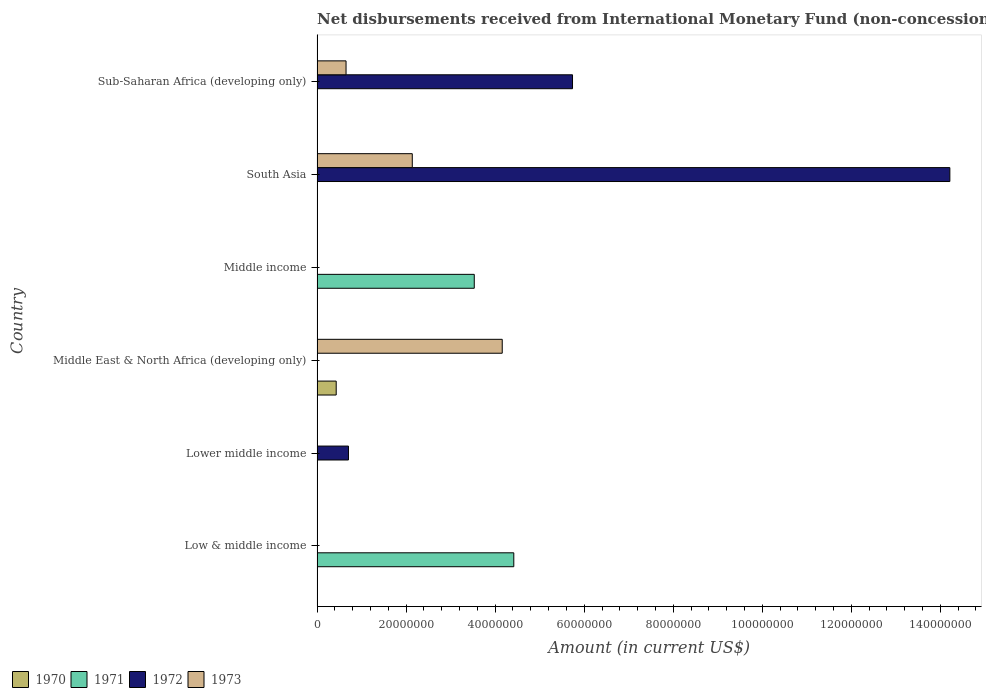Are the number of bars on each tick of the Y-axis equal?
Provide a short and direct response. No. What is the label of the 2nd group of bars from the top?
Your answer should be very brief. South Asia. What is the amount of disbursements received from International Monetary Fund in 1971 in Lower middle income?
Give a very brief answer. 0. Across all countries, what is the maximum amount of disbursements received from International Monetary Fund in 1972?
Your answer should be compact. 1.42e+08. Across all countries, what is the minimum amount of disbursements received from International Monetary Fund in 1973?
Offer a very short reply. 0. In which country was the amount of disbursements received from International Monetary Fund in 1970 maximum?
Your response must be concise. Middle East & North Africa (developing only). What is the total amount of disbursements received from International Monetary Fund in 1971 in the graph?
Ensure brevity in your answer.  7.95e+07. What is the difference between the amount of disbursements received from International Monetary Fund in 1971 in Low & middle income and that in Middle income?
Ensure brevity in your answer.  8.88e+06. What is the difference between the amount of disbursements received from International Monetary Fund in 1970 in South Asia and the amount of disbursements received from International Monetary Fund in 1972 in Sub-Saharan Africa (developing only)?
Offer a very short reply. -5.74e+07. What is the average amount of disbursements received from International Monetary Fund in 1973 per country?
Give a very brief answer. 1.16e+07. What is the difference between the amount of disbursements received from International Monetary Fund in 1973 and amount of disbursements received from International Monetary Fund in 1970 in Middle East & North Africa (developing only)?
Your answer should be compact. 3.73e+07. In how many countries, is the amount of disbursements received from International Monetary Fund in 1972 greater than 24000000 US$?
Keep it short and to the point. 2. Is the amount of disbursements received from International Monetary Fund in 1971 in Low & middle income less than that in Middle income?
Give a very brief answer. No. What is the difference between the highest and the second highest amount of disbursements received from International Monetary Fund in 1972?
Keep it short and to the point. 8.48e+07. What is the difference between the highest and the lowest amount of disbursements received from International Monetary Fund in 1973?
Provide a succinct answer. 4.16e+07. In how many countries, is the amount of disbursements received from International Monetary Fund in 1971 greater than the average amount of disbursements received from International Monetary Fund in 1971 taken over all countries?
Give a very brief answer. 2. Is the sum of the amount of disbursements received from International Monetary Fund in 1973 in Middle East & North Africa (developing only) and Sub-Saharan Africa (developing only) greater than the maximum amount of disbursements received from International Monetary Fund in 1971 across all countries?
Give a very brief answer. Yes. Is it the case that in every country, the sum of the amount of disbursements received from International Monetary Fund in 1971 and amount of disbursements received from International Monetary Fund in 1973 is greater than the sum of amount of disbursements received from International Monetary Fund in 1972 and amount of disbursements received from International Monetary Fund in 1970?
Your answer should be very brief. No. Is it the case that in every country, the sum of the amount of disbursements received from International Monetary Fund in 1973 and amount of disbursements received from International Monetary Fund in 1971 is greater than the amount of disbursements received from International Monetary Fund in 1972?
Your answer should be compact. No. How many bars are there?
Your answer should be very brief. 9. Are all the bars in the graph horizontal?
Your response must be concise. Yes. What is the difference between two consecutive major ticks on the X-axis?
Your response must be concise. 2.00e+07. Are the values on the major ticks of X-axis written in scientific E-notation?
Your answer should be compact. No. Does the graph contain grids?
Your response must be concise. No. Where does the legend appear in the graph?
Your response must be concise. Bottom left. How many legend labels are there?
Your answer should be compact. 4. How are the legend labels stacked?
Offer a very short reply. Horizontal. What is the title of the graph?
Offer a terse response. Net disbursements received from International Monetary Fund (non-concessional). What is the label or title of the X-axis?
Your answer should be compact. Amount (in current US$). What is the label or title of the Y-axis?
Your response must be concise. Country. What is the Amount (in current US$) of 1970 in Low & middle income?
Your answer should be compact. 0. What is the Amount (in current US$) of 1971 in Low & middle income?
Your answer should be compact. 4.42e+07. What is the Amount (in current US$) of 1972 in Low & middle income?
Provide a short and direct response. 0. What is the Amount (in current US$) in 1971 in Lower middle income?
Your response must be concise. 0. What is the Amount (in current US$) in 1972 in Lower middle income?
Offer a very short reply. 7.06e+06. What is the Amount (in current US$) of 1973 in Lower middle income?
Keep it short and to the point. 0. What is the Amount (in current US$) in 1970 in Middle East & North Africa (developing only)?
Offer a very short reply. 4.30e+06. What is the Amount (in current US$) of 1972 in Middle East & North Africa (developing only)?
Your response must be concise. 0. What is the Amount (in current US$) of 1973 in Middle East & North Africa (developing only)?
Ensure brevity in your answer.  4.16e+07. What is the Amount (in current US$) in 1970 in Middle income?
Offer a terse response. 0. What is the Amount (in current US$) in 1971 in Middle income?
Your response must be concise. 3.53e+07. What is the Amount (in current US$) of 1973 in Middle income?
Your answer should be very brief. 0. What is the Amount (in current US$) of 1970 in South Asia?
Provide a succinct answer. 0. What is the Amount (in current US$) in 1972 in South Asia?
Provide a succinct answer. 1.42e+08. What is the Amount (in current US$) in 1973 in South Asia?
Offer a terse response. 2.14e+07. What is the Amount (in current US$) of 1970 in Sub-Saharan Africa (developing only)?
Ensure brevity in your answer.  0. What is the Amount (in current US$) in 1971 in Sub-Saharan Africa (developing only)?
Make the answer very short. 0. What is the Amount (in current US$) of 1972 in Sub-Saharan Africa (developing only)?
Offer a terse response. 5.74e+07. What is the Amount (in current US$) of 1973 in Sub-Saharan Africa (developing only)?
Your answer should be very brief. 6.51e+06. Across all countries, what is the maximum Amount (in current US$) in 1970?
Give a very brief answer. 4.30e+06. Across all countries, what is the maximum Amount (in current US$) of 1971?
Your answer should be very brief. 4.42e+07. Across all countries, what is the maximum Amount (in current US$) in 1972?
Provide a succinct answer. 1.42e+08. Across all countries, what is the maximum Amount (in current US$) of 1973?
Provide a succinct answer. 4.16e+07. Across all countries, what is the minimum Amount (in current US$) of 1970?
Provide a succinct answer. 0. Across all countries, what is the minimum Amount (in current US$) in 1973?
Your answer should be compact. 0. What is the total Amount (in current US$) of 1970 in the graph?
Make the answer very short. 4.30e+06. What is the total Amount (in current US$) in 1971 in the graph?
Keep it short and to the point. 7.95e+07. What is the total Amount (in current US$) of 1972 in the graph?
Provide a succinct answer. 2.07e+08. What is the total Amount (in current US$) in 1973 in the graph?
Your answer should be very brief. 6.95e+07. What is the difference between the Amount (in current US$) in 1971 in Low & middle income and that in Middle income?
Your answer should be compact. 8.88e+06. What is the difference between the Amount (in current US$) of 1972 in Lower middle income and that in South Asia?
Keep it short and to the point. -1.35e+08. What is the difference between the Amount (in current US$) in 1972 in Lower middle income and that in Sub-Saharan Africa (developing only)?
Your response must be concise. -5.03e+07. What is the difference between the Amount (in current US$) of 1973 in Middle East & North Africa (developing only) and that in South Asia?
Offer a very short reply. 2.02e+07. What is the difference between the Amount (in current US$) of 1973 in Middle East & North Africa (developing only) and that in Sub-Saharan Africa (developing only)?
Your answer should be very brief. 3.51e+07. What is the difference between the Amount (in current US$) in 1972 in South Asia and that in Sub-Saharan Africa (developing only)?
Ensure brevity in your answer.  8.48e+07. What is the difference between the Amount (in current US$) in 1973 in South Asia and that in Sub-Saharan Africa (developing only)?
Make the answer very short. 1.49e+07. What is the difference between the Amount (in current US$) of 1971 in Low & middle income and the Amount (in current US$) of 1972 in Lower middle income?
Give a very brief answer. 3.71e+07. What is the difference between the Amount (in current US$) in 1971 in Low & middle income and the Amount (in current US$) in 1973 in Middle East & North Africa (developing only)?
Your answer should be compact. 2.60e+06. What is the difference between the Amount (in current US$) of 1971 in Low & middle income and the Amount (in current US$) of 1972 in South Asia?
Provide a succinct answer. -9.79e+07. What is the difference between the Amount (in current US$) of 1971 in Low & middle income and the Amount (in current US$) of 1973 in South Asia?
Provide a short and direct response. 2.28e+07. What is the difference between the Amount (in current US$) in 1971 in Low & middle income and the Amount (in current US$) in 1972 in Sub-Saharan Africa (developing only)?
Ensure brevity in your answer.  -1.32e+07. What is the difference between the Amount (in current US$) in 1971 in Low & middle income and the Amount (in current US$) in 1973 in Sub-Saharan Africa (developing only)?
Provide a succinct answer. 3.77e+07. What is the difference between the Amount (in current US$) of 1972 in Lower middle income and the Amount (in current US$) of 1973 in Middle East & North Africa (developing only)?
Ensure brevity in your answer.  -3.45e+07. What is the difference between the Amount (in current US$) in 1972 in Lower middle income and the Amount (in current US$) in 1973 in South Asia?
Provide a short and direct response. -1.43e+07. What is the difference between the Amount (in current US$) in 1972 in Lower middle income and the Amount (in current US$) in 1973 in Sub-Saharan Africa (developing only)?
Provide a short and direct response. 5.46e+05. What is the difference between the Amount (in current US$) of 1970 in Middle East & North Africa (developing only) and the Amount (in current US$) of 1971 in Middle income?
Give a very brief answer. -3.10e+07. What is the difference between the Amount (in current US$) in 1970 in Middle East & North Africa (developing only) and the Amount (in current US$) in 1972 in South Asia?
Ensure brevity in your answer.  -1.38e+08. What is the difference between the Amount (in current US$) in 1970 in Middle East & North Africa (developing only) and the Amount (in current US$) in 1973 in South Asia?
Provide a short and direct response. -1.71e+07. What is the difference between the Amount (in current US$) in 1970 in Middle East & North Africa (developing only) and the Amount (in current US$) in 1972 in Sub-Saharan Africa (developing only)?
Keep it short and to the point. -5.31e+07. What is the difference between the Amount (in current US$) of 1970 in Middle East & North Africa (developing only) and the Amount (in current US$) of 1973 in Sub-Saharan Africa (developing only)?
Give a very brief answer. -2.21e+06. What is the difference between the Amount (in current US$) of 1971 in Middle income and the Amount (in current US$) of 1972 in South Asia?
Your response must be concise. -1.07e+08. What is the difference between the Amount (in current US$) in 1971 in Middle income and the Amount (in current US$) in 1973 in South Asia?
Your answer should be very brief. 1.39e+07. What is the difference between the Amount (in current US$) of 1971 in Middle income and the Amount (in current US$) of 1972 in Sub-Saharan Africa (developing only)?
Offer a terse response. -2.21e+07. What is the difference between the Amount (in current US$) in 1971 in Middle income and the Amount (in current US$) in 1973 in Sub-Saharan Africa (developing only)?
Offer a very short reply. 2.88e+07. What is the difference between the Amount (in current US$) of 1972 in South Asia and the Amount (in current US$) of 1973 in Sub-Saharan Africa (developing only)?
Make the answer very short. 1.36e+08. What is the average Amount (in current US$) of 1970 per country?
Your answer should be very brief. 7.17e+05. What is the average Amount (in current US$) in 1971 per country?
Keep it short and to the point. 1.32e+07. What is the average Amount (in current US$) of 1972 per country?
Provide a short and direct response. 3.44e+07. What is the average Amount (in current US$) in 1973 per country?
Your answer should be very brief. 1.16e+07. What is the difference between the Amount (in current US$) of 1970 and Amount (in current US$) of 1973 in Middle East & North Africa (developing only)?
Keep it short and to the point. -3.73e+07. What is the difference between the Amount (in current US$) of 1972 and Amount (in current US$) of 1973 in South Asia?
Your response must be concise. 1.21e+08. What is the difference between the Amount (in current US$) in 1972 and Amount (in current US$) in 1973 in Sub-Saharan Africa (developing only)?
Keep it short and to the point. 5.09e+07. What is the ratio of the Amount (in current US$) of 1971 in Low & middle income to that in Middle income?
Provide a succinct answer. 1.25. What is the ratio of the Amount (in current US$) of 1972 in Lower middle income to that in South Asia?
Your response must be concise. 0.05. What is the ratio of the Amount (in current US$) in 1972 in Lower middle income to that in Sub-Saharan Africa (developing only)?
Make the answer very short. 0.12. What is the ratio of the Amount (in current US$) of 1973 in Middle East & North Africa (developing only) to that in South Asia?
Offer a terse response. 1.94. What is the ratio of the Amount (in current US$) in 1973 in Middle East & North Africa (developing only) to that in Sub-Saharan Africa (developing only)?
Your response must be concise. 6.39. What is the ratio of the Amount (in current US$) of 1972 in South Asia to that in Sub-Saharan Africa (developing only)?
Your response must be concise. 2.48. What is the ratio of the Amount (in current US$) of 1973 in South Asia to that in Sub-Saharan Africa (developing only)?
Your answer should be compact. 3.29. What is the difference between the highest and the second highest Amount (in current US$) of 1972?
Your answer should be compact. 8.48e+07. What is the difference between the highest and the second highest Amount (in current US$) in 1973?
Ensure brevity in your answer.  2.02e+07. What is the difference between the highest and the lowest Amount (in current US$) in 1970?
Keep it short and to the point. 4.30e+06. What is the difference between the highest and the lowest Amount (in current US$) of 1971?
Keep it short and to the point. 4.42e+07. What is the difference between the highest and the lowest Amount (in current US$) of 1972?
Make the answer very short. 1.42e+08. What is the difference between the highest and the lowest Amount (in current US$) in 1973?
Offer a terse response. 4.16e+07. 